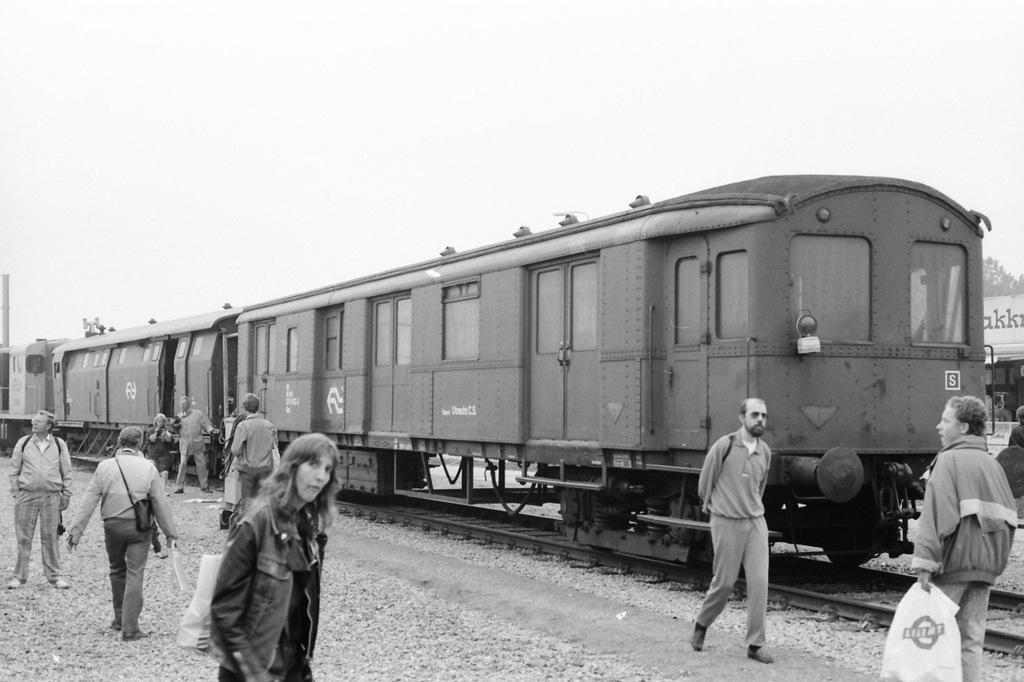How many persons are visible in the image? There are persons on either side of the image. What is the main subject in the middle of the image? There is a train in the middle of the image. What is visible at the top of the image? The sky is visible at the top of the image. What color scheme is used in the image? The image is in black and white color. Can you tell me how many chess pieces are on the side of the train in the image? There is no chess or chess pieces present in the image. What type of tax is being discussed by the persons on either side of the image? There is no discussion of tax or any other topic in the image; it only shows persons on either side of a train. 